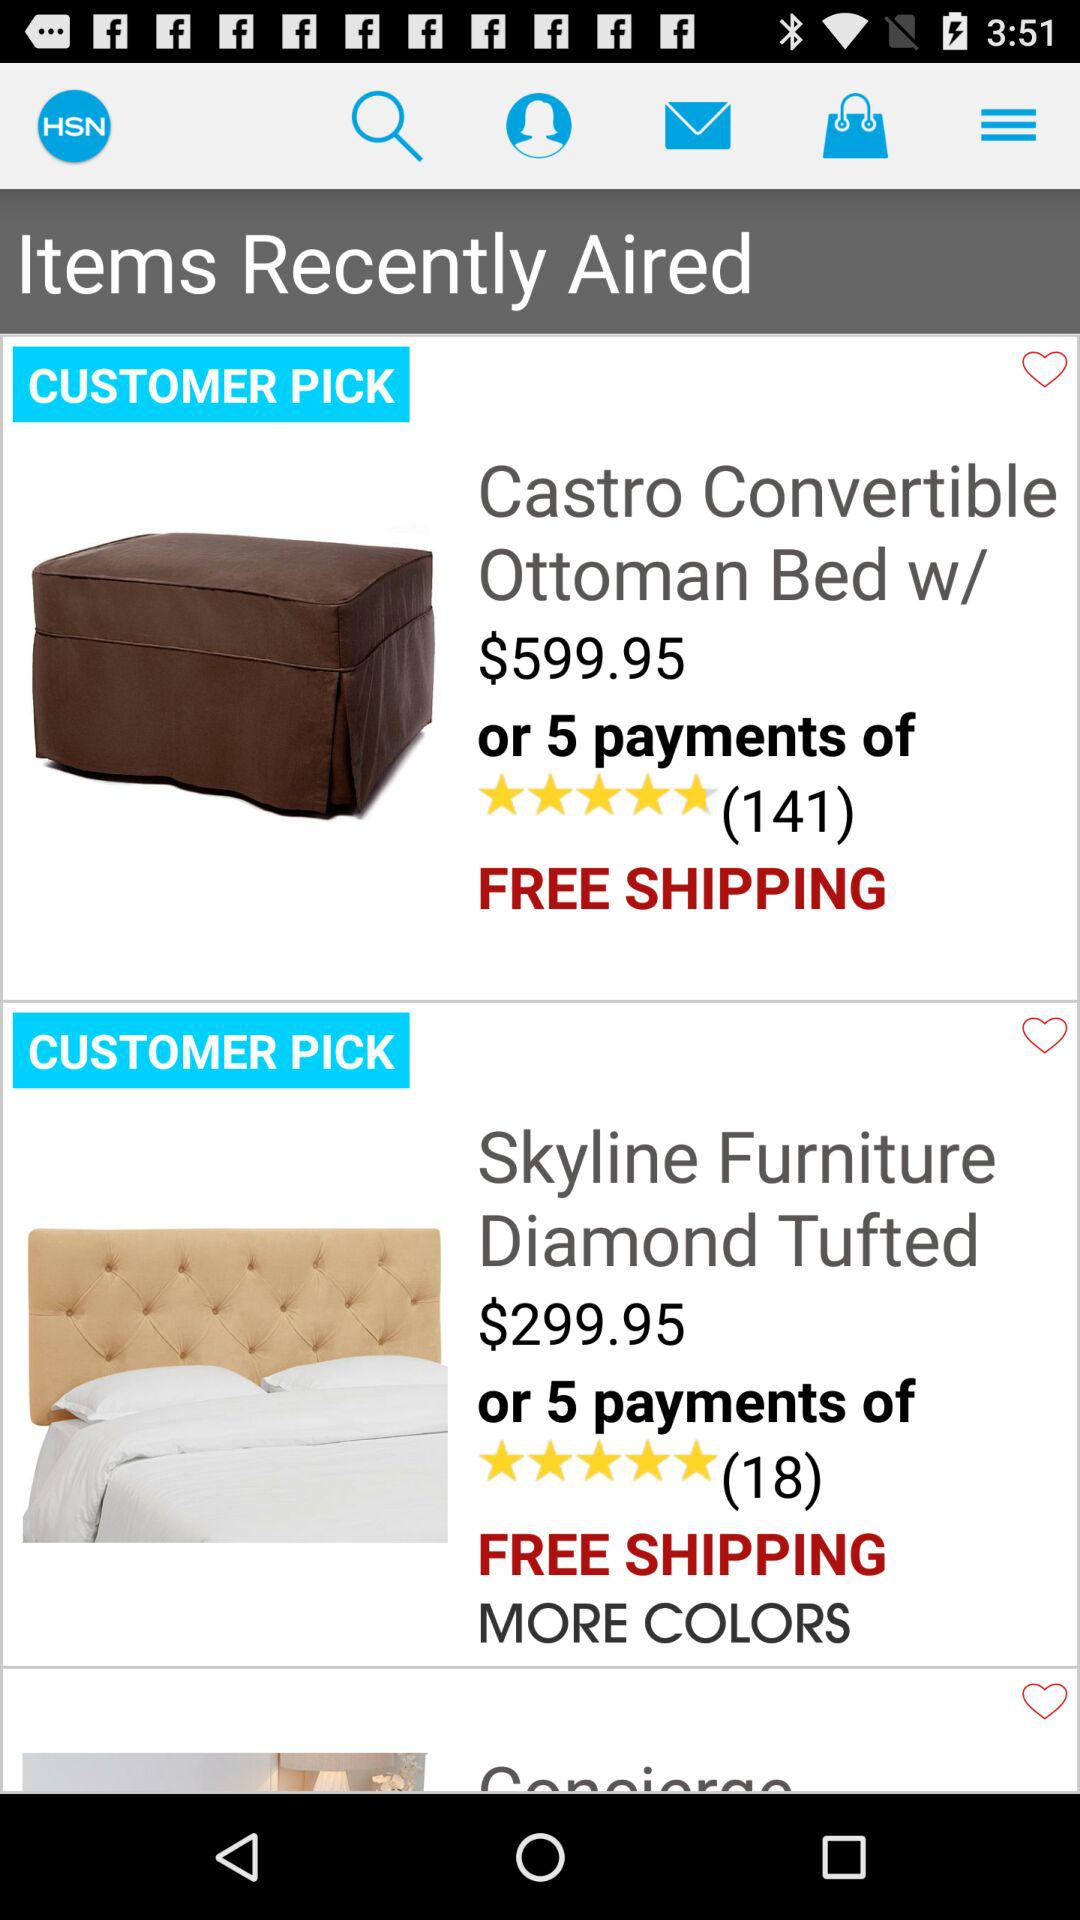How many customers gave a rating to "Skyline Furniture Diamond Tufted"? The number of customers who gave a rating to "Skyline Furniture Diamond Tufted" is 18. 